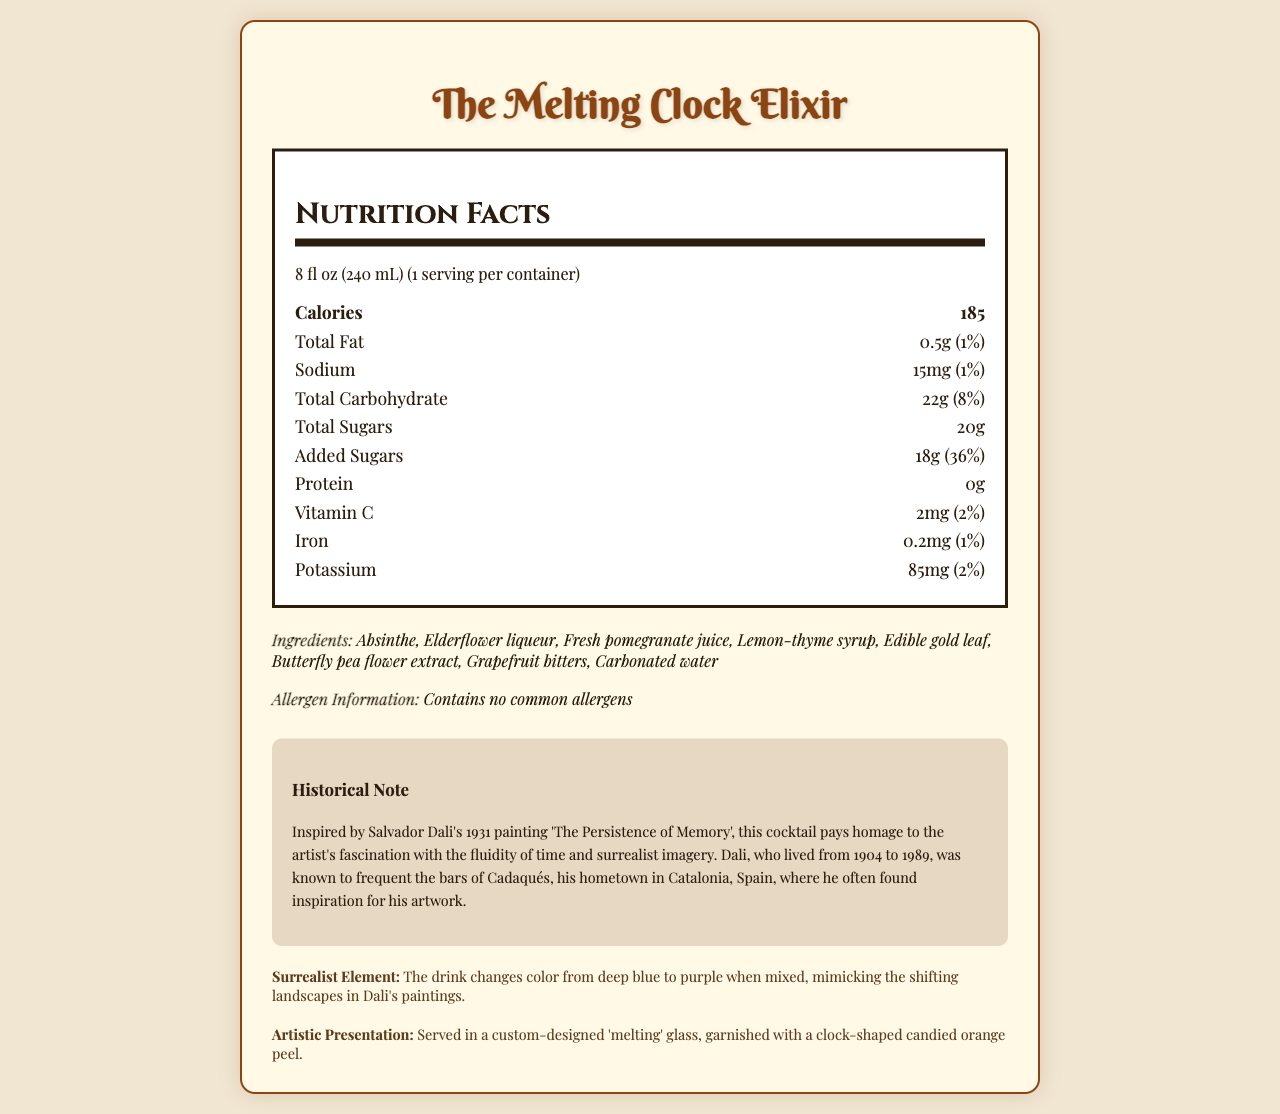what is the serving size? The serving size is explicitly stated at the beginning of the nutrition facts section.
Answer: 8 fl oz (240 mL) what are the total calories per serving? The number of calories per serving is listed at the beginning of the nutrition facts section.
Answer: 185 how much sodium is in The Melting Clock Elixir? The amount of sodium per serving is listed in the nutrition facts section.
Answer: 15mg what percent of the daily value of vitamin C does one serving provide? The daily value percentage for vitamin C is listed under the nutrition facts section.
Answer: 2% how many grams of total carbohydrates are in one serving? The total carbohydrate content is listed in the nutrition facts section.
Answer: 22g which of the following ingredients is NOT in The Melting Clock Elixir? A) Absinthe B) Elderflower liqueur C) Blue Curacao D) Butterfly pea flower extract Blue Curacao is not listed among the ingredients in the ingredients section.
Answer: C) Blue Curacao what unconventional ingredient is used to create the surrealist color change effect? A) Edible gold leaf B) Lemon-thyme syrup C) Butterfly pea flower extract D) Grapefruit bitters The surrealist element describes the color change effect and mentions the butterfly pea flower extract.
Answer: C) Butterfly pea flower extract is The Melting Clock Elixir allergen-free? The allergen information states that it contains no common allergens.
Answer: Yes describe the main idea of The Melting Clock Elixir's nutrition facts and artistic elements. The document combines detailed nutritional information with artistic elements inspired by Salvador Dali's work, highlighting the cocktail's unique ingredients and visual transformation.
Answer: The Melting Clock Elixir is a unique cocktail inspired by Salvador Dali's surrealist artwork. It features unconventional ingredients like absinthe, elderflower liqueur, and butterfly pea flower extract, and is presented in a custom-designed 'melting' glass. The nutrition facts indicate it has 185 calories per serving, with low fat and sodium, but high sugars. The drink changes color from deep blue to purple when mixed, mimicking surrealist landscapes. who inspired The Melting Clock Elixir? The historical note mentions that the cocktail is inspired by Salvador Dali's painting "The Persistence of Memory."
Answer: Salvador Dali how many grams of added sugars are in the cocktail? The nutrition facts section lists the amount of added sugars.
Answer: 18g does the drink contain any protein? The nutrition facts section indicates that there are 0g of protein in the cocktail.
Answer: No what is the artistic presentation of The Melting Clock Elixir? The artistic presentation section describes how the drink is served and garnished.
Answer: The drink is served in a custom-designed 'melting' glass, garnished with a clock-shaped candied orange peel. which of the following is a characteristic of The Melting Clock Elixir? A) High protein content B) Contains dairy analogues C) Changes color when mixed D) Rich in fiber The surrealist element section mentions that the drink changes color from deep blue to purple when mixed.
Answer: C) Changes color when mixed how much potassium does one serving of The Melting Clock Elixir contain? The amount of potassium is listed under the nutrition facts section.
Answer: 85mg what is the total fat content in the cocktail? The total fat content per serving is listed in the nutrition facts section.
Answer: 0.5g what is Salvador Dali's connection to Cadaqués? The historical note section mentions Salvador Dali's connection to Cadaqués and its impact on his creative process.
Answer: Dali was known to frequent the bars of Cadaqués, his hometown in Catalonia, Spain, where he often found inspiration for his artwork. how many servings are in one container of The Melting Clock Elixir? The number of servings per container is stated at the beginning of the nutrition facts section.
Answer: 1 what is the iron content of The Melting Clock Elixir per serving? The iron content is listed in the nutrition facts section.
Answer: 0.2mg what year was 'The Persistence of Memory' painted? The historical note section states that 'The Persistence of Memory' was painted in 1931.
Answer: 1931 who designed the 'melting' glass for The Melting Clock Elixir? The document does not provide information about the designer of the 'melting' glass.
Answer: Cannot be determined 